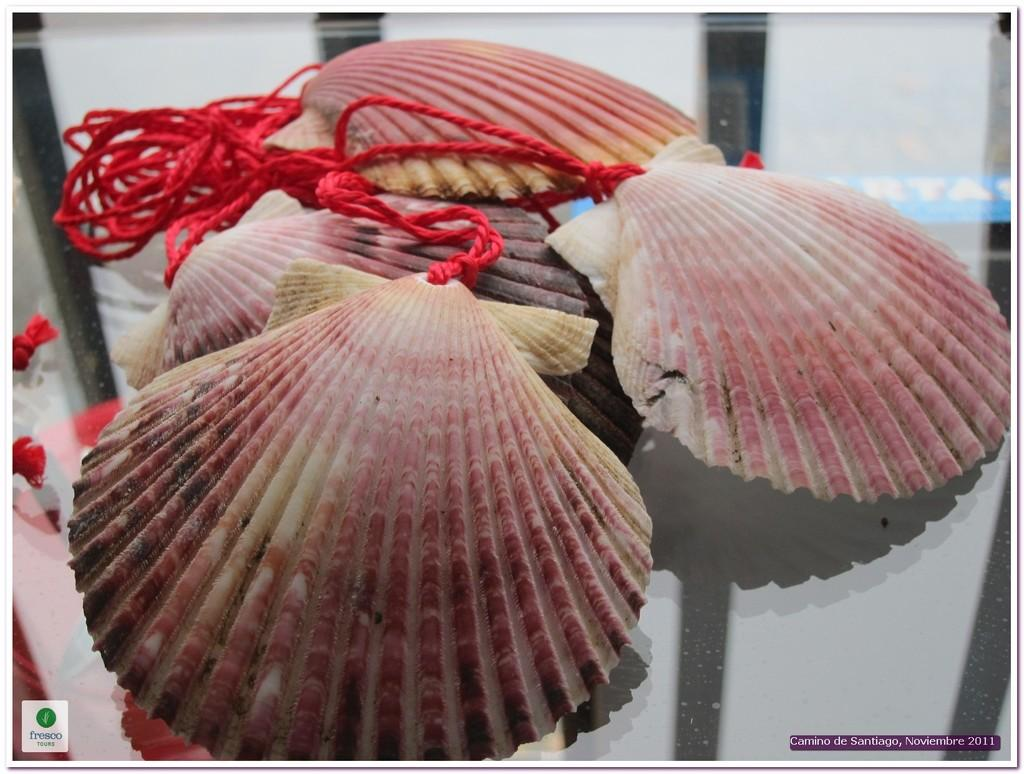What type of objects can be seen in the image? There are shells in the image. How are the shells connected or arranged? Ropes are connected to the shells. Is there any text present in the image? Yes, there is some text at the bottom of the image. What does the son say in the caption of the image? There is no son or caption present in the image. What type of farming equipment is connected to the shells in the image? There is no farming equipment, such as a yoke, connected to the shells in the image. 